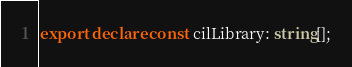<code> <loc_0><loc_0><loc_500><loc_500><_TypeScript_>export declare const cilLibrary: string[];</code> 